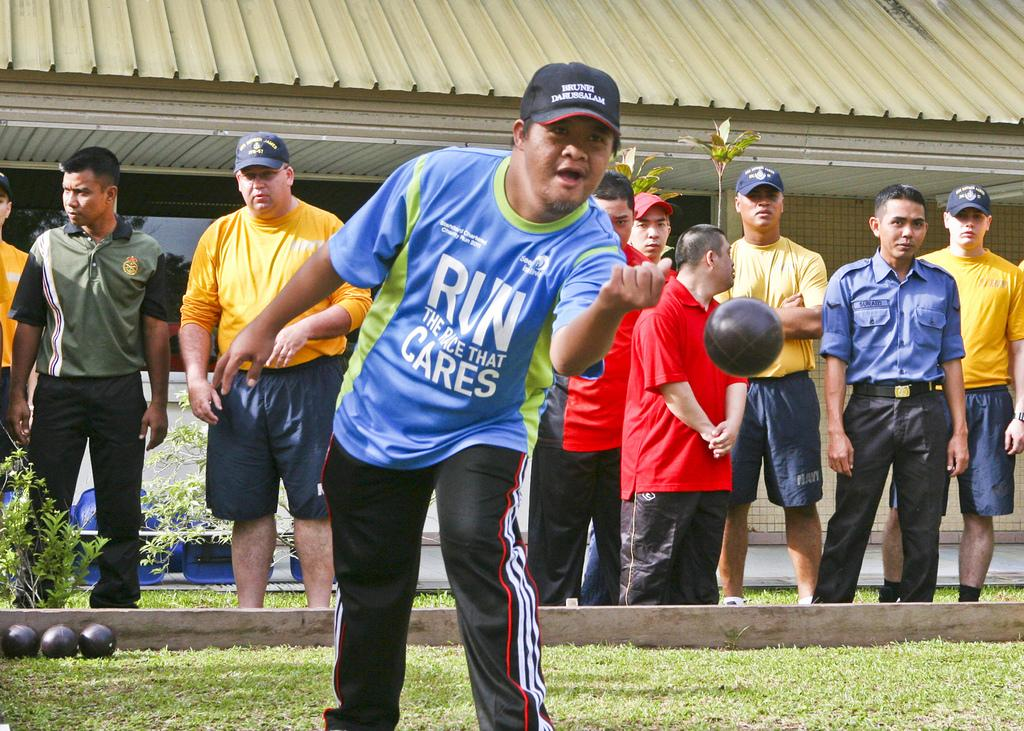<image>
Write a terse but informative summary of the picture. Man wearing a tshirt that says "RUN" throwing a ball. 